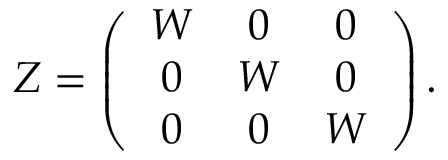Convert formula to latex. <formula><loc_0><loc_0><loc_500><loc_500>Z = \left ( \begin{array} { c c c } { W } & { 0 } & { 0 } \\ { 0 } & { W } & { 0 } \\ { 0 } & { 0 } & { W } \end{array} \right ) .</formula> 